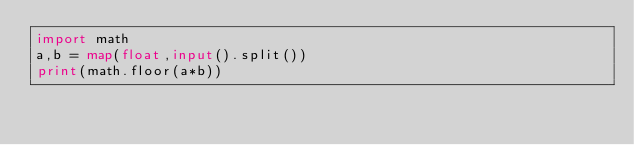<code> <loc_0><loc_0><loc_500><loc_500><_Python_>import math
a,b = map(float,input().split())
print(math.floor(a*b))</code> 